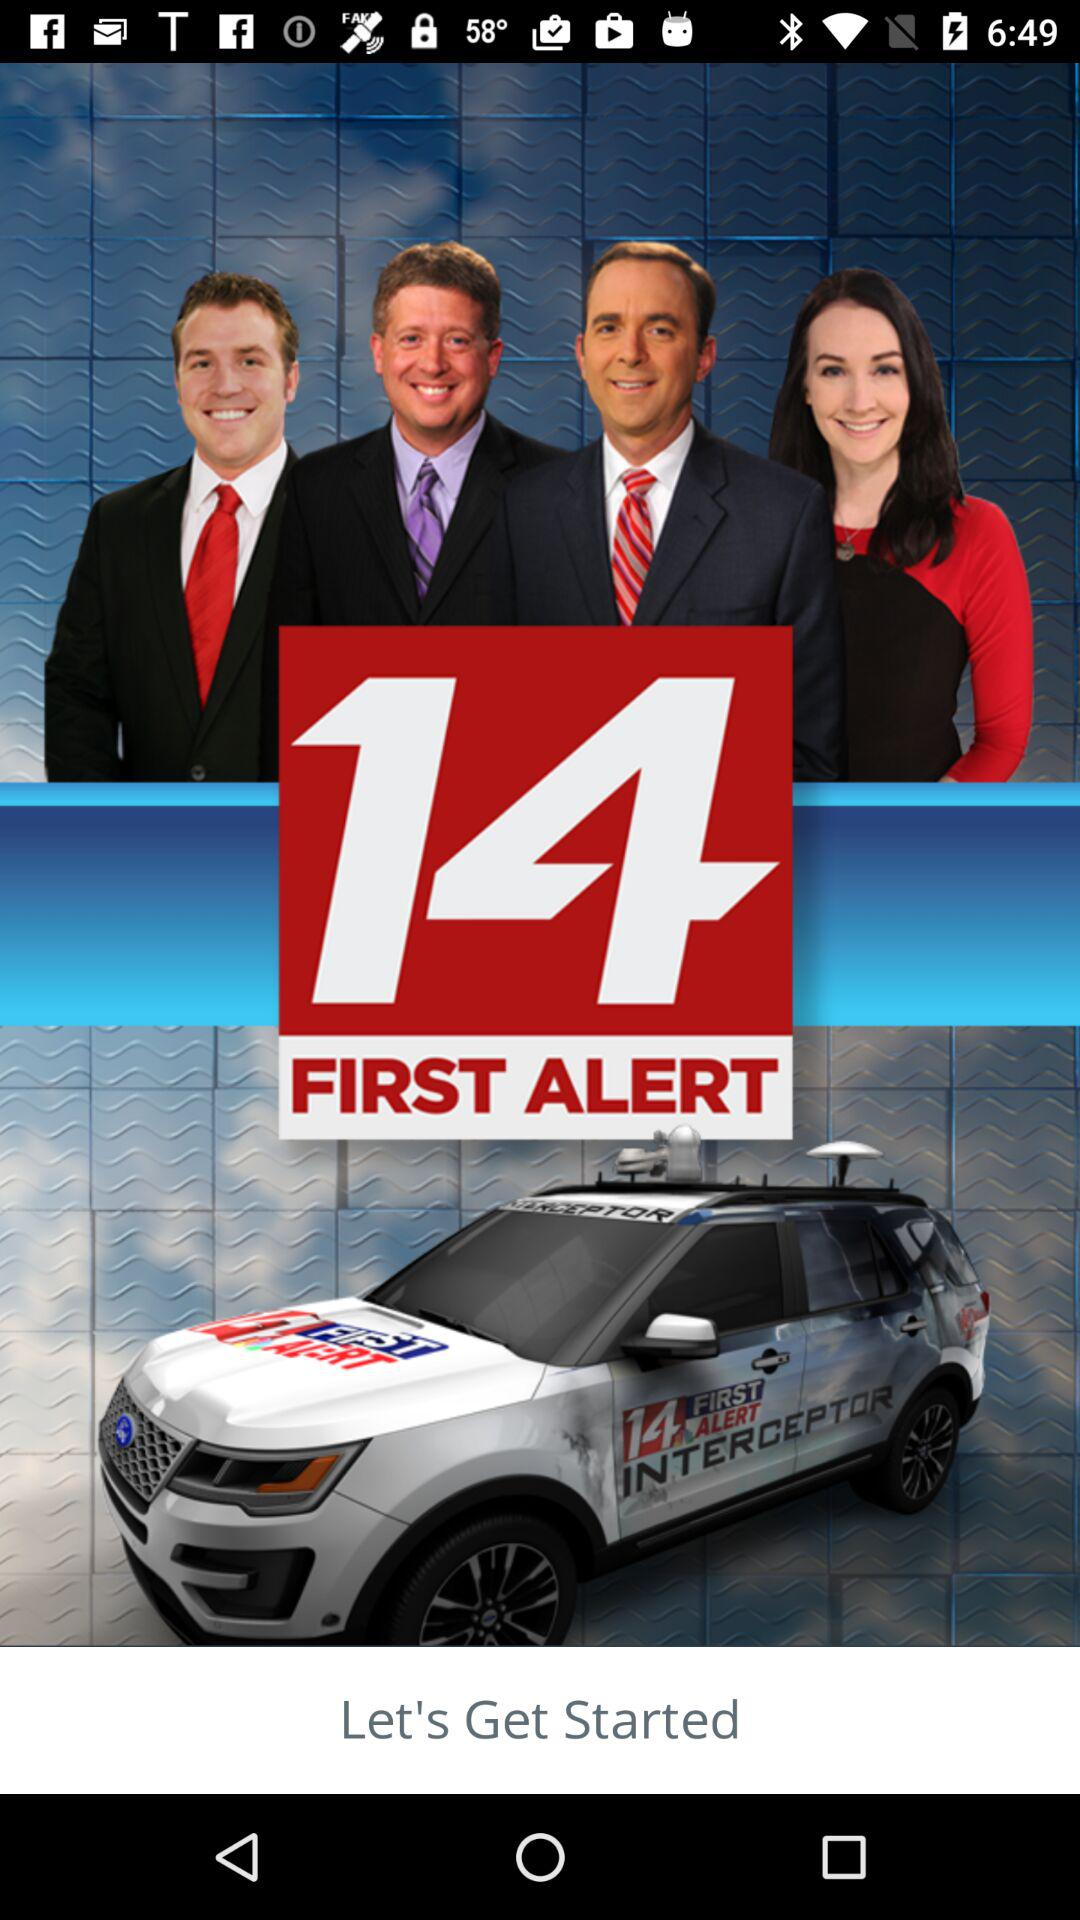What is the name of the application? The name of the application is "14 FIRST ALERT". 